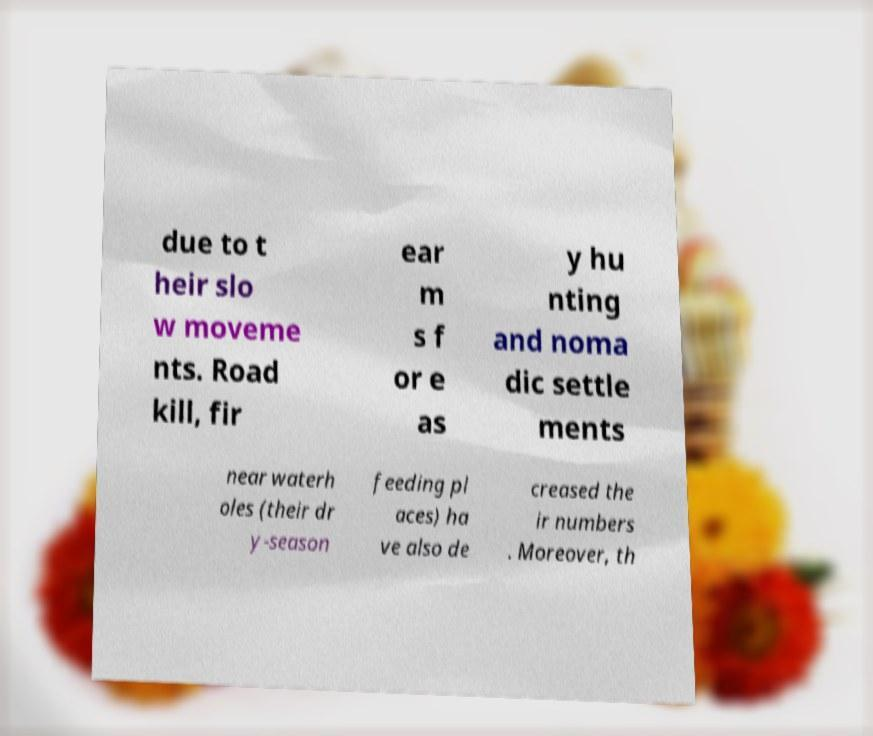Could you extract and type out the text from this image? due to t heir slo w moveme nts. Road kill, fir ear m s f or e as y hu nting and noma dic settle ments near waterh oles (their dr y-season feeding pl aces) ha ve also de creased the ir numbers . Moreover, th 